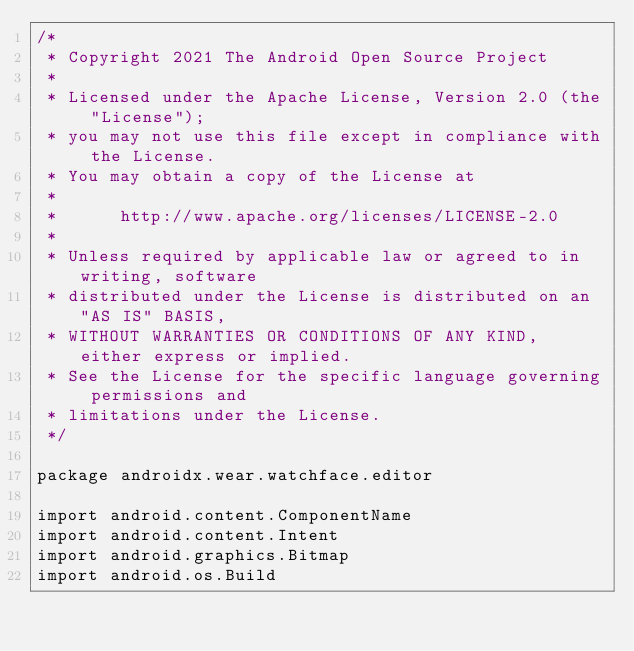<code> <loc_0><loc_0><loc_500><loc_500><_Kotlin_>/*
 * Copyright 2021 The Android Open Source Project
 *
 * Licensed under the Apache License, Version 2.0 (the "License");
 * you may not use this file except in compliance with the License.
 * You may obtain a copy of the License at
 *
 *      http://www.apache.org/licenses/LICENSE-2.0
 *
 * Unless required by applicable law or agreed to in writing, software
 * distributed under the License is distributed on an "AS IS" BASIS,
 * WITHOUT WARRANTIES OR CONDITIONS OF ANY KIND, either express or implied.
 * See the License for the specific language governing permissions and
 * limitations under the License.
 */

package androidx.wear.watchface.editor

import android.content.ComponentName
import android.content.Intent
import android.graphics.Bitmap
import android.os.Build</code> 